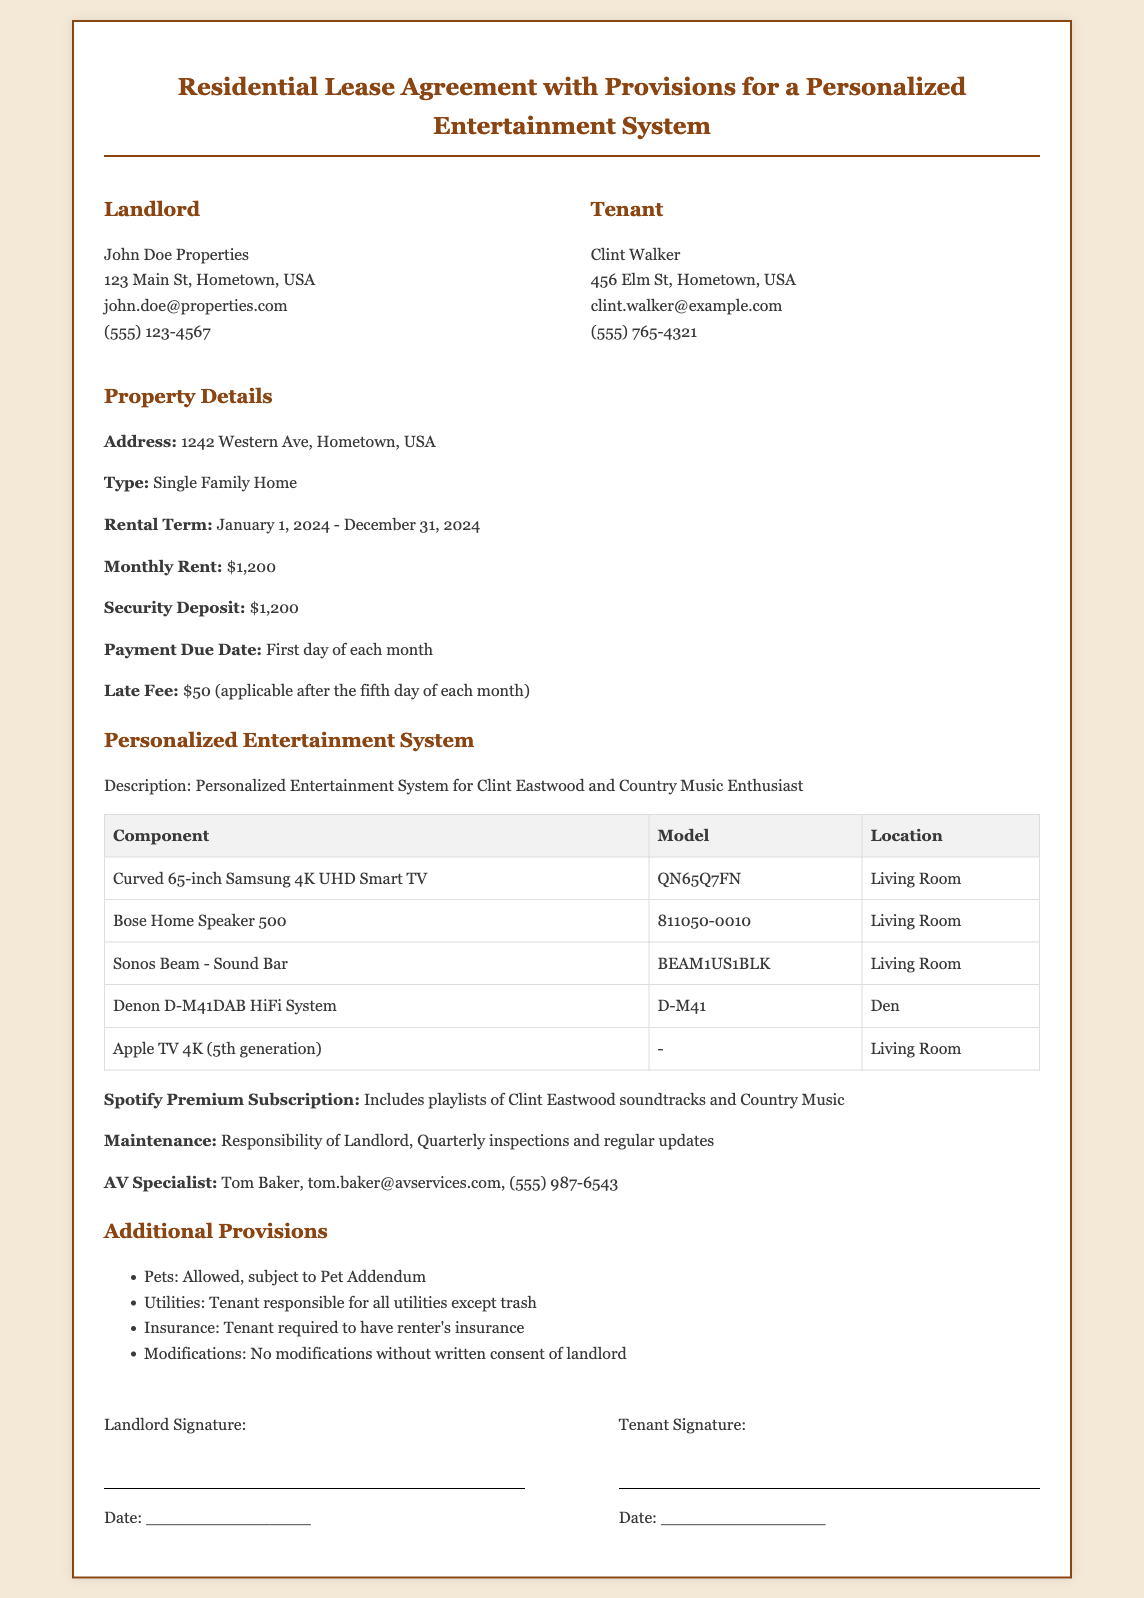What is the monthly rent? The monthly rent is specified in the Property Details section of the document.
Answer: $1,200 Who is the tenant? The tenant's name is listed under the Tenant section.
Answer: Clint Walker What is the security deposit amount? The security deposit amount is provided in the Property Details section.
Answer: $1,200 What is the late fee after the fifth day? The late fee is mentioned in the Property Details section.
Answer: $50 Who is responsible for maintaining the entertainment system? The maintenance responsibilities are outlined in the Personalized Entertainment System section.
Answer: Landlord Which room contains the Bose Home Speaker 500? The location of the Bose Home Speaker is specified in the table of components.
Answer: Living Room What is the rental term duration? The rental term is outlined in the Property Details section of the document.
Answer: January 1, 2024 - December 31, 2024 Is renter's insurance required? This requirement is mentioned in the Additional Provisions section.
Answer: Yes Can the tenant make modifications without consent? This question refers to the modifications policy in the Additional Provisions section.
Answer: No 